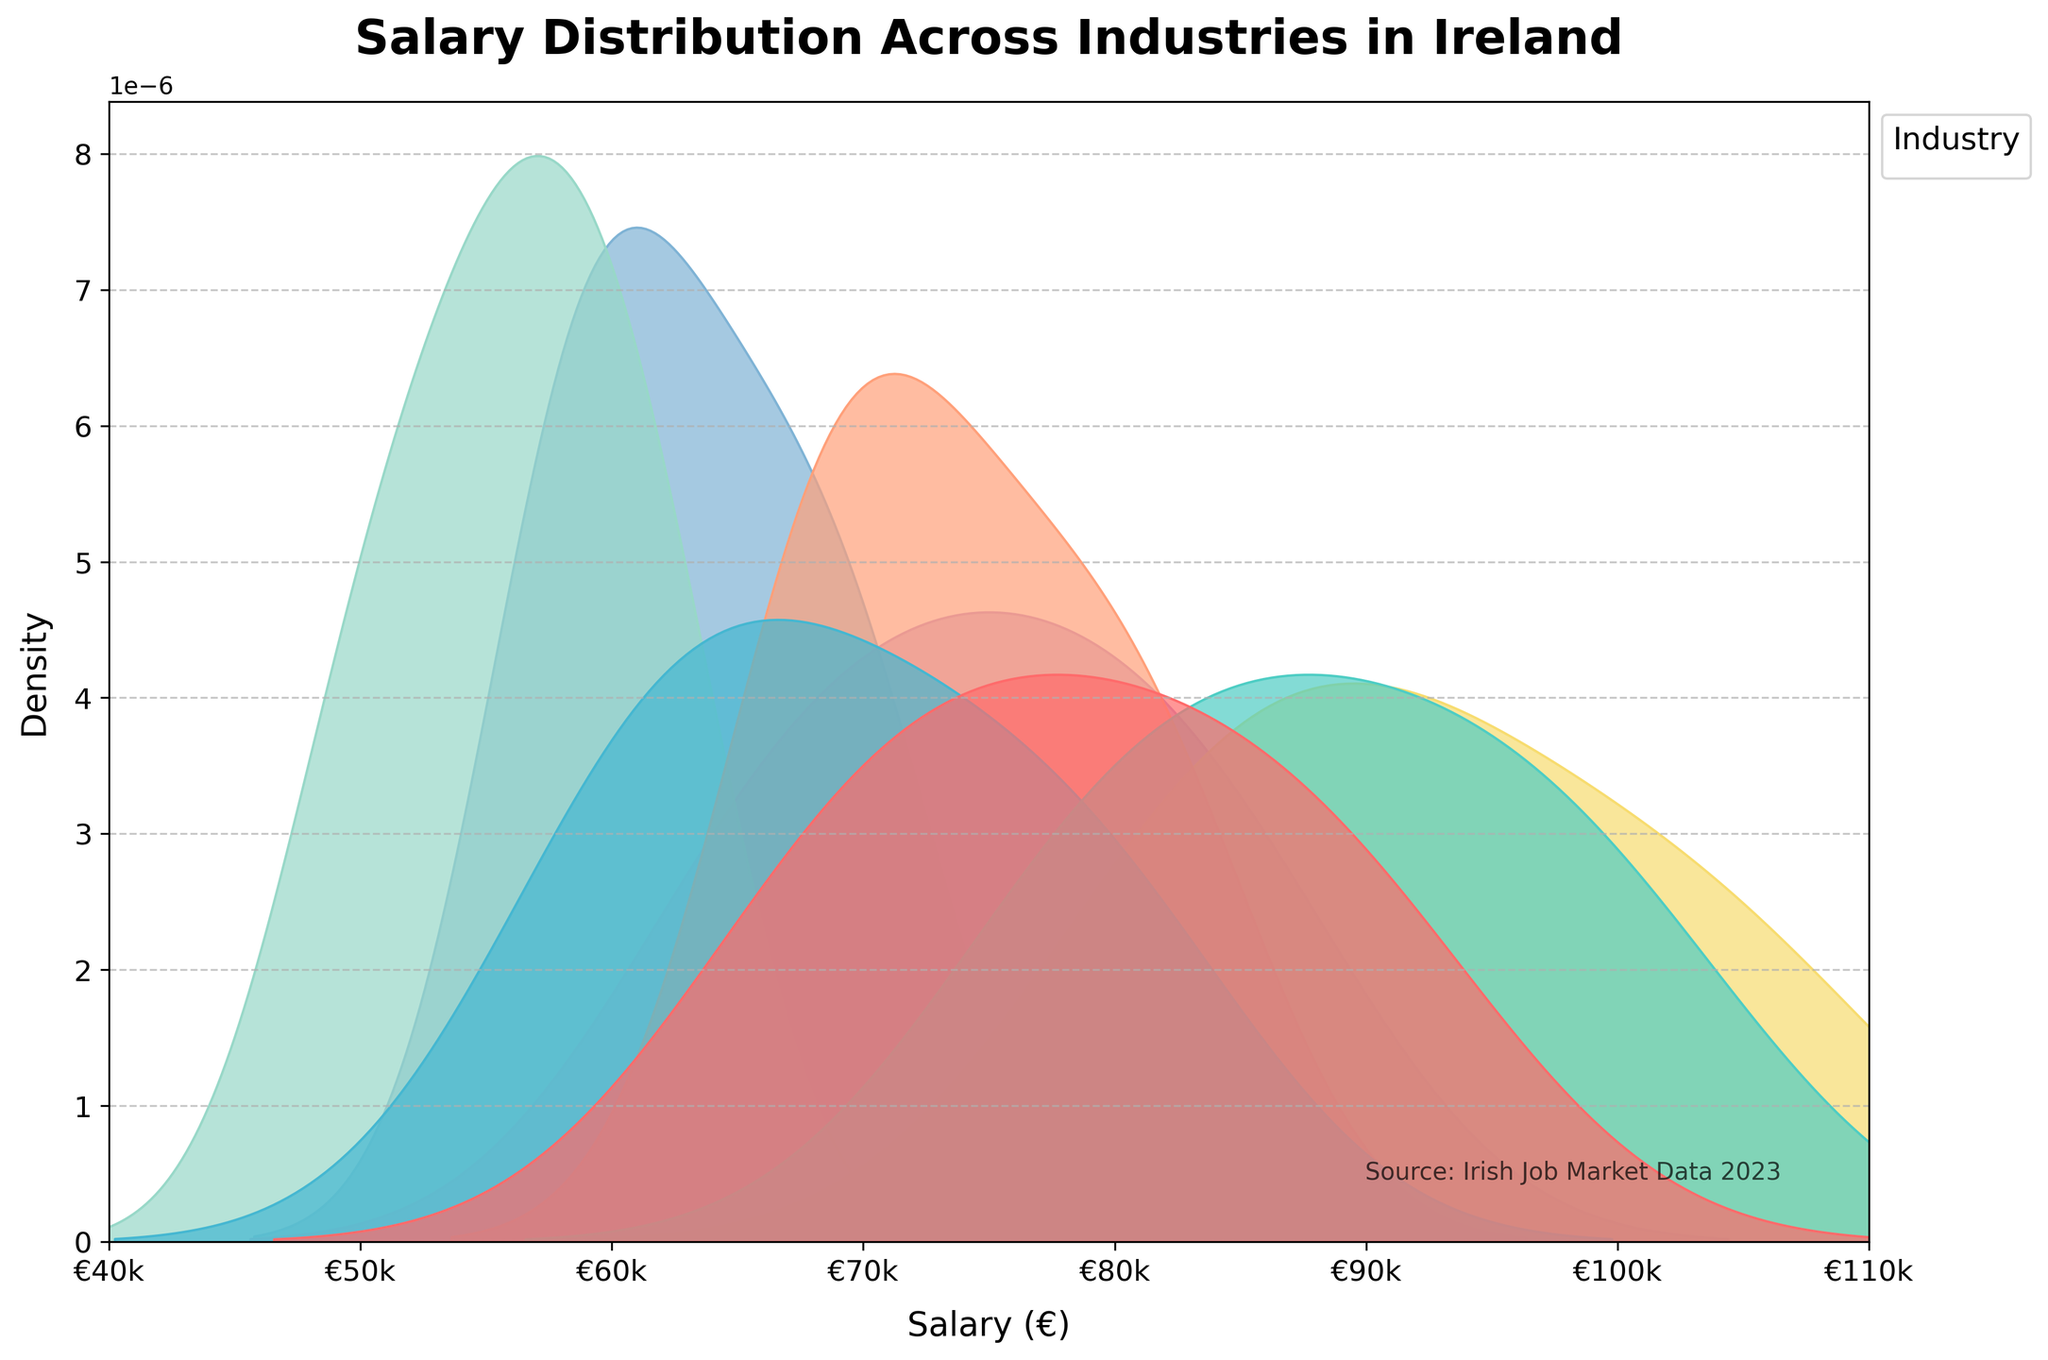What is the title of the density plot? The title of the plot is written at the top and usually describes the overall content being visualized.
Answer: Salary Distribution Across Industries in Ireland What is the approximate salary range for the Finance industry? By looking at the density peaks and spread for the Finance industry, we can observe the range of salaries. The highest density indicates the salary range within one standard deviation of the mean.
Answer: Roughly €78k - €100k Which industry has the highest peak density in the salary distribution? The highest peak density indicates the most common salary within an industry. Identifying this requires comparing the heights of the peaks for each industry on the plot.
Answer: Education What is the salary range where the Technology and Retail industry densities overlap the most? This requires identifying where the density curves of Technology and Retail intersect and overlap significantly.
Answer: Around €68k - €75k Which industry appears to have the most varied salary distribution? The varied salary distribution is indicated by the spread of the density curve. A wider spread signifies a more diverse range of salaries.
Answer: Pharmaceuticals Approximately, around what salary does the Technology industry's salary density peak? To find the peak density for Technology, observe the salary value at which Technology has its highest density value.
Answer: Around €75k Between Healthcare and Marketing, which industry shows a narrower spread in salary distribution? A narrower spread can be identified by the compactness of the peak. Smaller spread means less variation in salaries.
Answer: Healthcare At what approximate salary does the density for the Education industry start to taper off significantly? The tapering off point is where the density curve starts to decline significantly on the right side.
Answer: Around €62k What is the overall trend observed in the salary distributions across different industries in Ireland? The overall trend depicts how salaries are distributed across different industries, revealing information like common salary ranges and industry comparisons.
Answer: Varied distribution with higher density peaks in mid-range salaries around €60k-€80k and wider spread in some industries like Pharmaceuticals In which salary intervals do Technology and Finance show significant overlaps? The significant overlap can be observed around the similar peaks and where their density curves intersect or converge.
Answer: Around €78k - €92k 